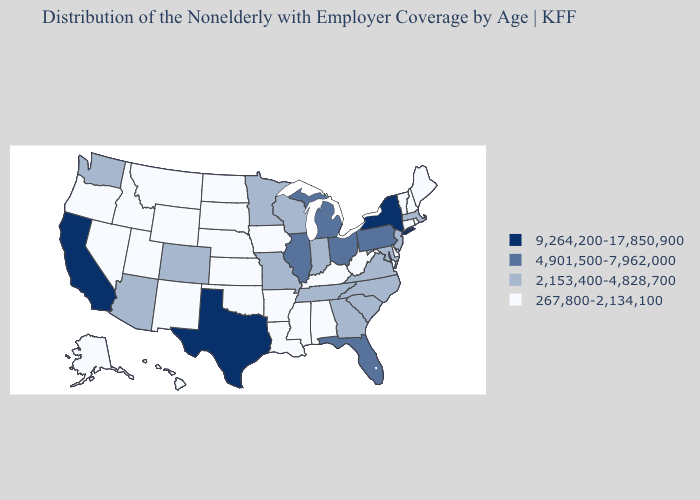Which states hav the highest value in the West?
Answer briefly. California. What is the lowest value in states that border North Carolina?
Be succinct. 2,153,400-4,828,700. Name the states that have a value in the range 2,153,400-4,828,700?
Short answer required. Arizona, Colorado, Georgia, Indiana, Maryland, Massachusetts, Minnesota, Missouri, New Jersey, North Carolina, South Carolina, Tennessee, Virginia, Washington, Wisconsin. Does Kansas have the lowest value in the MidWest?
Keep it brief. Yes. Is the legend a continuous bar?
Concise answer only. No. Name the states that have a value in the range 4,901,500-7,962,000?
Quick response, please. Florida, Illinois, Michigan, Ohio, Pennsylvania. Name the states that have a value in the range 9,264,200-17,850,900?
Answer briefly. California, New York, Texas. Does Ohio have the lowest value in the USA?
Answer briefly. No. Does the map have missing data?
Concise answer only. No. Does Rhode Island have the lowest value in the USA?
Be succinct. Yes. What is the highest value in the USA?
Answer briefly. 9,264,200-17,850,900. What is the value of Arkansas?
Write a very short answer. 267,800-2,134,100. What is the value of Nevada?
Keep it brief. 267,800-2,134,100. What is the value of Kansas?
Write a very short answer. 267,800-2,134,100. Among the states that border Mississippi , does Tennessee have the highest value?
Concise answer only. Yes. 